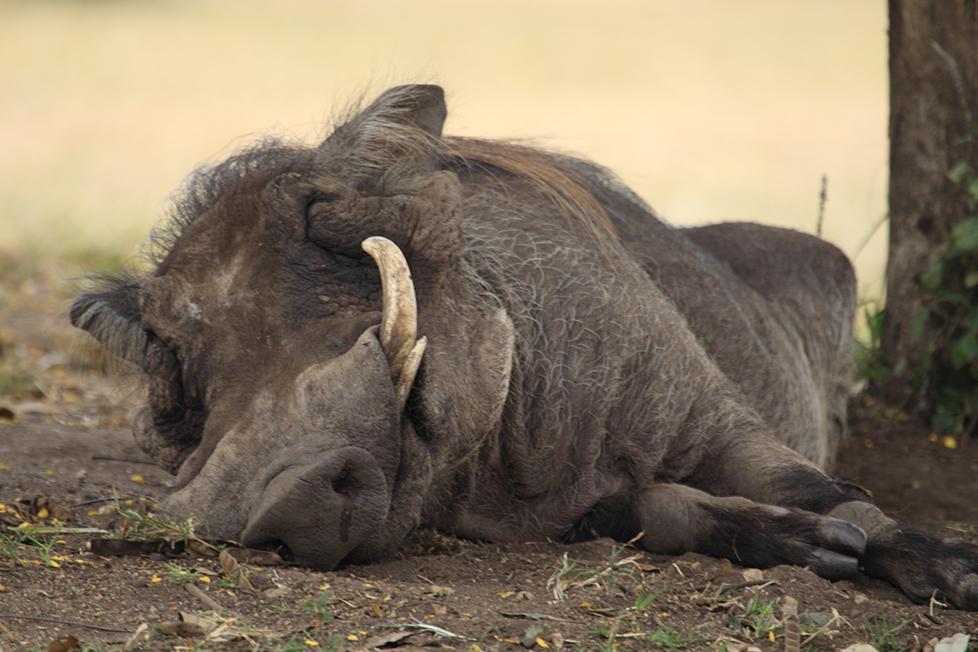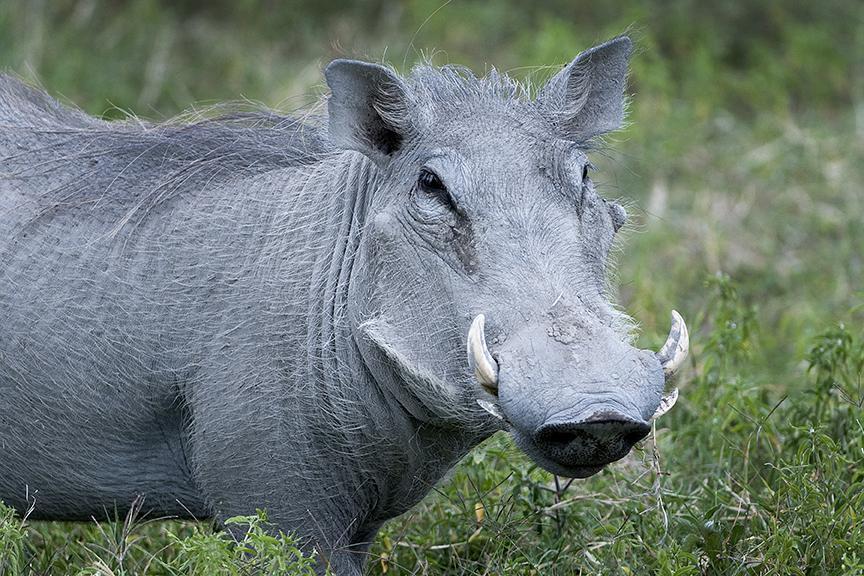The first image is the image on the left, the second image is the image on the right. For the images displayed, is the sentence "There are at least 4 hogs standing in grass." factually correct? Answer yes or no. No. 